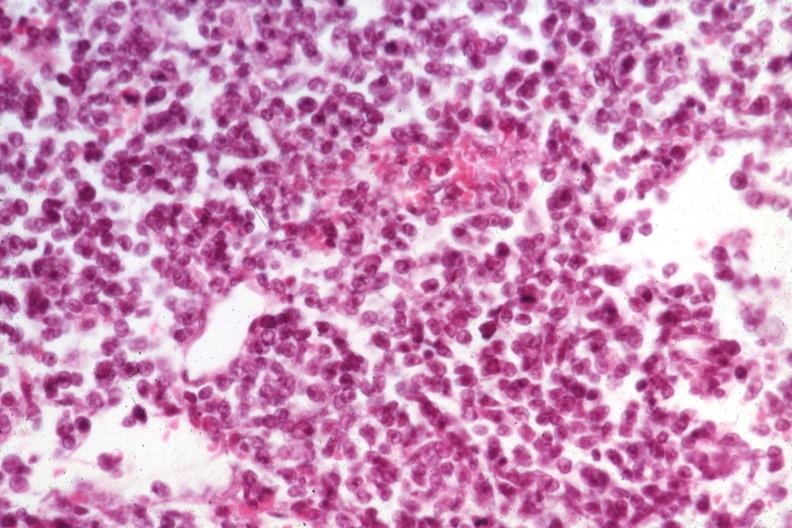s malignant lymphoma present?
Answer the question using a single word or phrase. Yes 